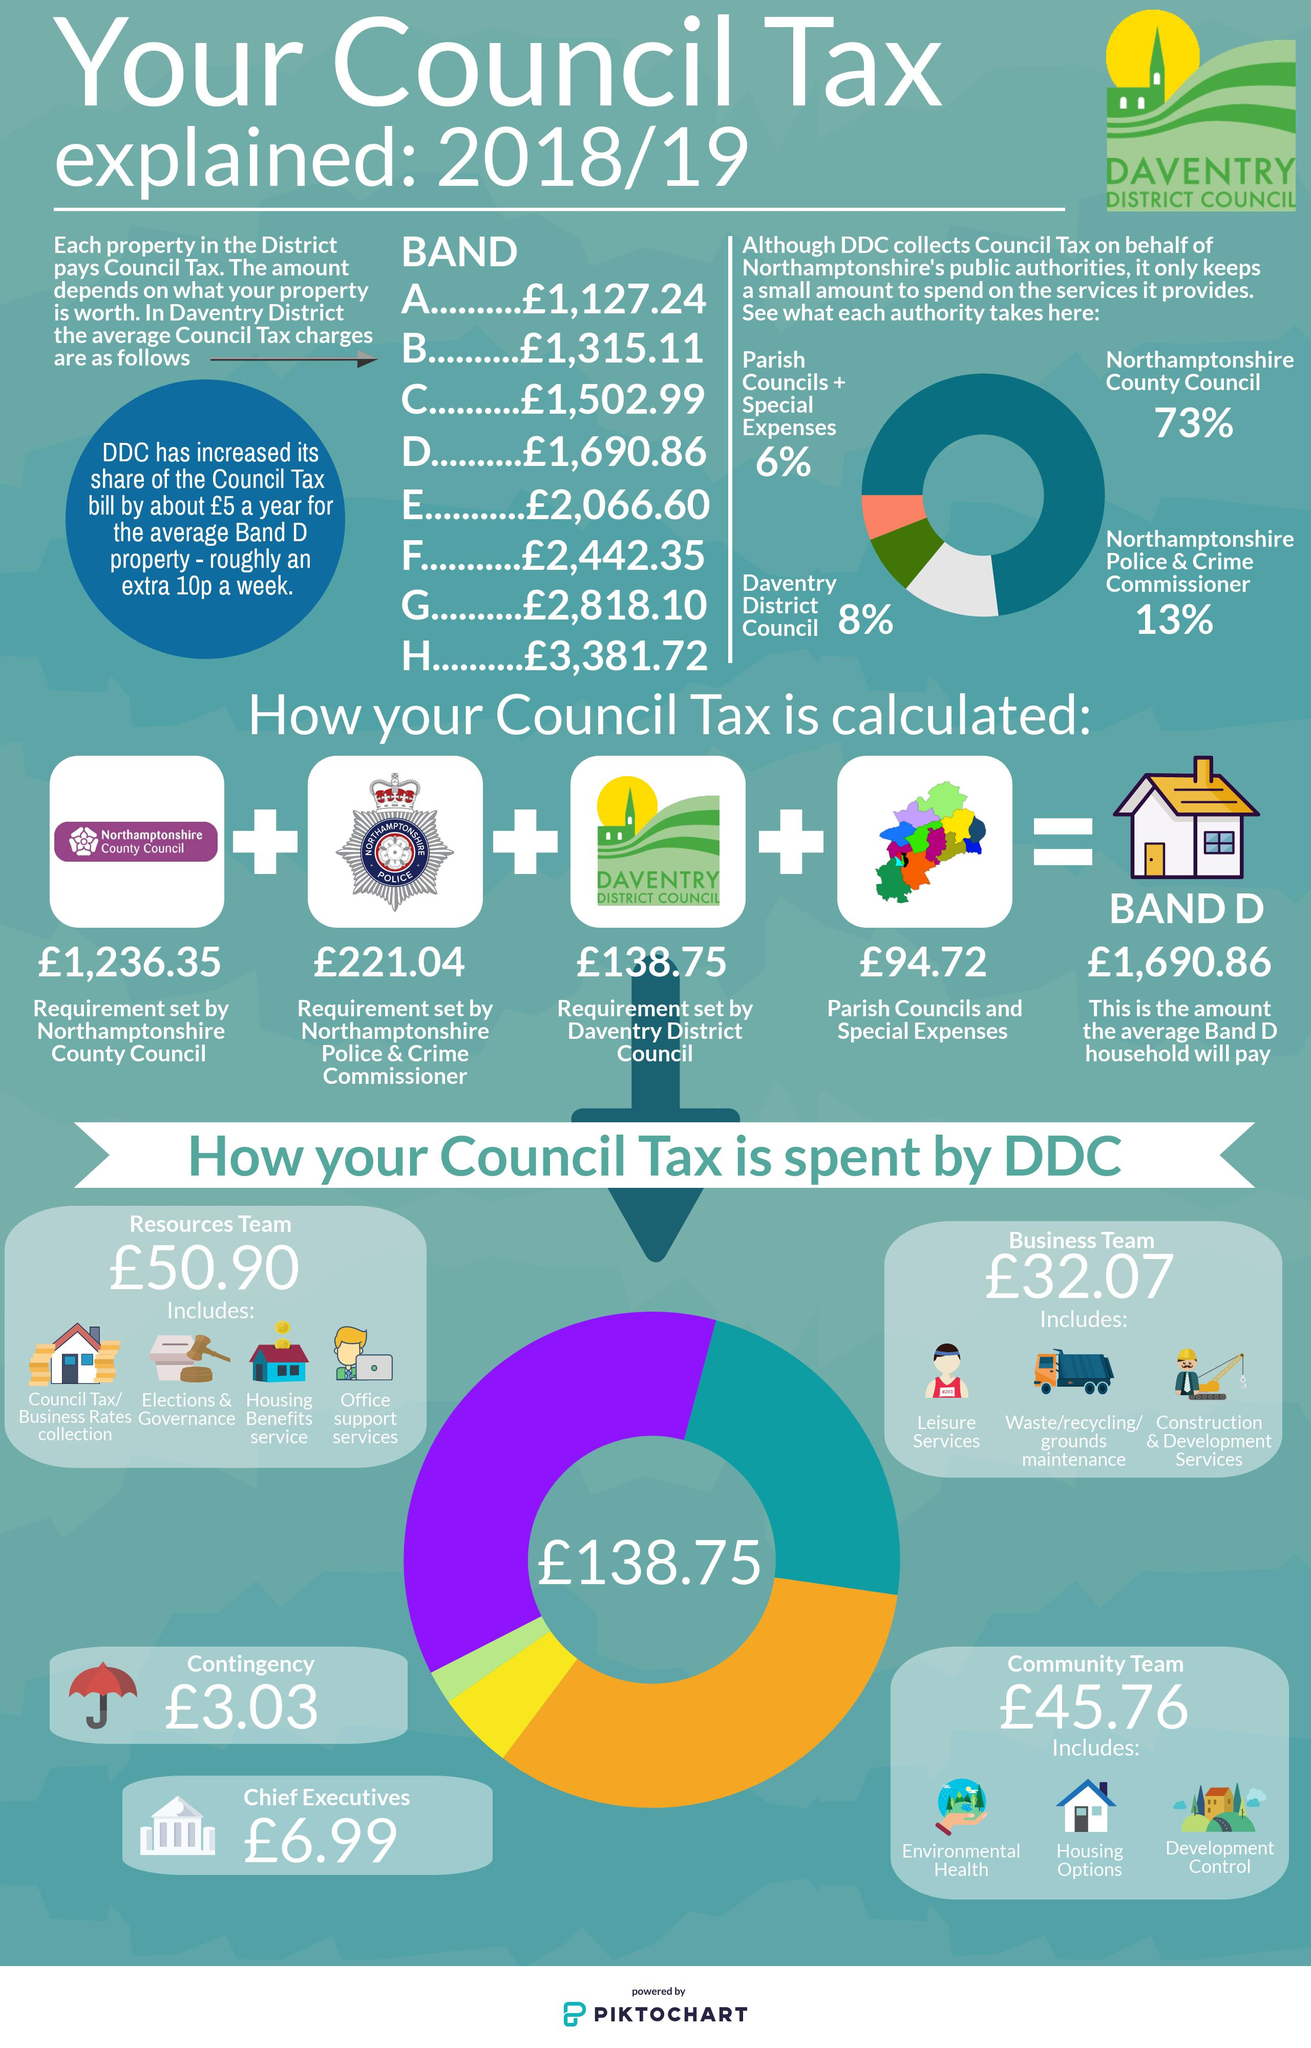Indicate a few pertinent items in this graphic. The total council tax to be paid by band A, B, and C is 3,945.34 pounds. The DDC takes 138.75 pounds from the total Council Tax calculated for Band D. The band that must pay the second highest council tax is Band G. The Northamptonshire Police & Crime Commissioner receives the second largest percentage of funding from the Council Tax, after the local authorities. The number of components included in the calculation of council tax for Band D is four. 